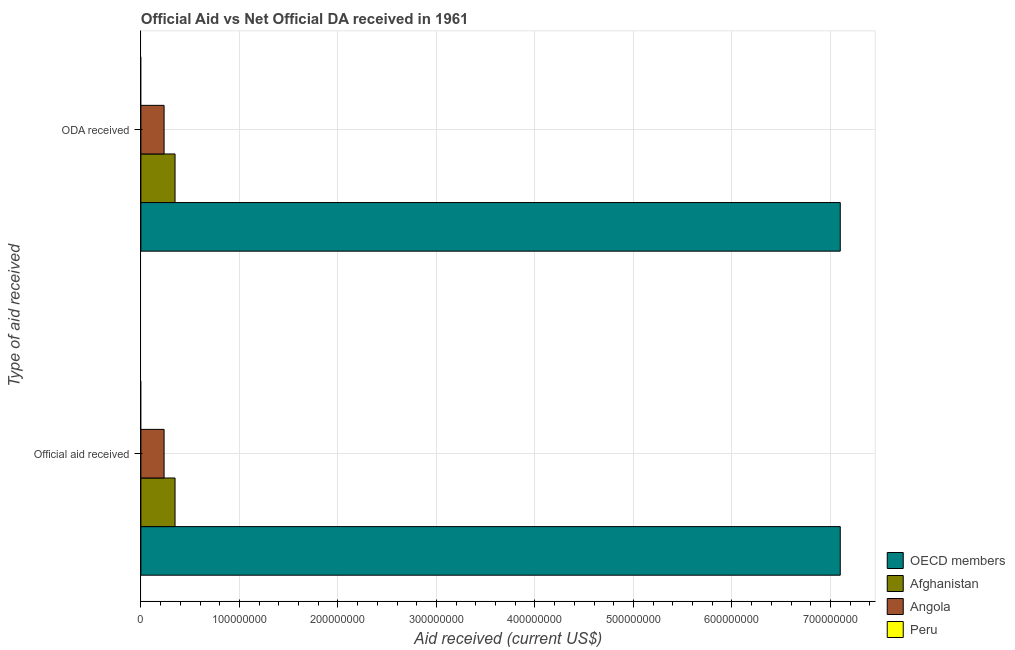How many groups of bars are there?
Keep it short and to the point. 2. How many bars are there on the 1st tick from the top?
Your response must be concise. 3. How many bars are there on the 1st tick from the bottom?
Provide a succinct answer. 3. What is the label of the 2nd group of bars from the top?
Offer a terse response. Official aid received. What is the official aid received in Angola?
Make the answer very short. 2.36e+07. Across all countries, what is the maximum oda received?
Your answer should be compact. 7.10e+08. What is the total official aid received in the graph?
Offer a terse response. 7.68e+08. What is the difference between the official aid received in OECD members and that in Angola?
Offer a terse response. 6.86e+08. What is the difference between the official aid received in Peru and the oda received in Angola?
Offer a terse response. -2.36e+07. What is the average official aid received per country?
Your answer should be compact. 1.92e+08. What is the ratio of the oda received in Afghanistan to that in OECD members?
Offer a terse response. 0.05. How many bars are there?
Provide a succinct answer. 6. How many countries are there in the graph?
Make the answer very short. 4. What is the difference between two consecutive major ticks on the X-axis?
Your answer should be very brief. 1.00e+08. Does the graph contain grids?
Provide a short and direct response. Yes. What is the title of the graph?
Offer a terse response. Official Aid vs Net Official DA received in 1961 . What is the label or title of the X-axis?
Ensure brevity in your answer.  Aid received (current US$). What is the label or title of the Y-axis?
Your answer should be compact. Type of aid received. What is the Aid received (current US$) of OECD members in Official aid received?
Offer a terse response. 7.10e+08. What is the Aid received (current US$) of Afghanistan in Official aid received?
Make the answer very short. 3.47e+07. What is the Aid received (current US$) in Angola in Official aid received?
Offer a very short reply. 2.36e+07. What is the Aid received (current US$) in OECD members in ODA received?
Keep it short and to the point. 7.10e+08. What is the Aid received (current US$) of Afghanistan in ODA received?
Your answer should be very brief. 3.47e+07. What is the Aid received (current US$) in Angola in ODA received?
Give a very brief answer. 2.36e+07. Across all Type of aid received, what is the maximum Aid received (current US$) of OECD members?
Provide a succinct answer. 7.10e+08. Across all Type of aid received, what is the maximum Aid received (current US$) in Afghanistan?
Provide a succinct answer. 3.47e+07. Across all Type of aid received, what is the maximum Aid received (current US$) in Angola?
Ensure brevity in your answer.  2.36e+07. Across all Type of aid received, what is the minimum Aid received (current US$) of OECD members?
Your response must be concise. 7.10e+08. Across all Type of aid received, what is the minimum Aid received (current US$) of Afghanistan?
Your answer should be very brief. 3.47e+07. Across all Type of aid received, what is the minimum Aid received (current US$) in Angola?
Offer a terse response. 2.36e+07. What is the total Aid received (current US$) in OECD members in the graph?
Ensure brevity in your answer.  1.42e+09. What is the total Aid received (current US$) in Afghanistan in the graph?
Provide a succinct answer. 6.93e+07. What is the total Aid received (current US$) of Angola in the graph?
Offer a very short reply. 4.71e+07. What is the total Aid received (current US$) in Peru in the graph?
Provide a succinct answer. 0. What is the difference between the Aid received (current US$) of OECD members in Official aid received and that in ODA received?
Offer a very short reply. 0. What is the difference between the Aid received (current US$) of Afghanistan in Official aid received and that in ODA received?
Keep it short and to the point. 0. What is the difference between the Aid received (current US$) in Angola in Official aid received and that in ODA received?
Your answer should be very brief. 0. What is the difference between the Aid received (current US$) in OECD members in Official aid received and the Aid received (current US$) in Afghanistan in ODA received?
Your response must be concise. 6.75e+08. What is the difference between the Aid received (current US$) of OECD members in Official aid received and the Aid received (current US$) of Angola in ODA received?
Offer a terse response. 6.86e+08. What is the difference between the Aid received (current US$) of Afghanistan in Official aid received and the Aid received (current US$) of Angola in ODA received?
Your answer should be very brief. 1.11e+07. What is the average Aid received (current US$) in OECD members per Type of aid received?
Your response must be concise. 7.10e+08. What is the average Aid received (current US$) of Afghanistan per Type of aid received?
Keep it short and to the point. 3.47e+07. What is the average Aid received (current US$) of Angola per Type of aid received?
Offer a terse response. 2.36e+07. What is the difference between the Aid received (current US$) of OECD members and Aid received (current US$) of Afghanistan in Official aid received?
Make the answer very short. 6.75e+08. What is the difference between the Aid received (current US$) of OECD members and Aid received (current US$) of Angola in Official aid received?
Your answer should be compact. 6.86e+08. What is the difference between the Aid received (current US$) of Afghanistan and Aid received (current US$) of Angola in Official aid received?
Offer a very short reply. 1.11e+07. What is the difference between the Aid received (current US$) of OECD members and Aid received (current US$) of Afghanistan in ODA received?
Your answer should be very brief. 6.75e+08. What is the difference between the Aid received (current US$) in OECD members and Aid received (current US$) in Angola in ODA received?
Provide a succinct answer. 6.86e+08. What is the difference between the Aid received (current US$) of Afghanistan and Aid received (current US$) of Angola in ODA received?
Make the answer very short. 1.11e+07. What is the ratio of the Aid received (current US$) in OECD members in Official aid received to that in ODA received?
Your response must be concise. 1. What is the ratio of the Aid received (current US$) in Afghanistan in Official aid received to that in ODA received?
Offer a very short reply. 1. What is the difference between the highest and the second highest Aid received (current US$) of Afghanistan?
Provide a short and direct response. 0. What is the difference between the highest and the lowest Aid received (current US$) of Afghanistan?
Provide a short and direct response. 0. 